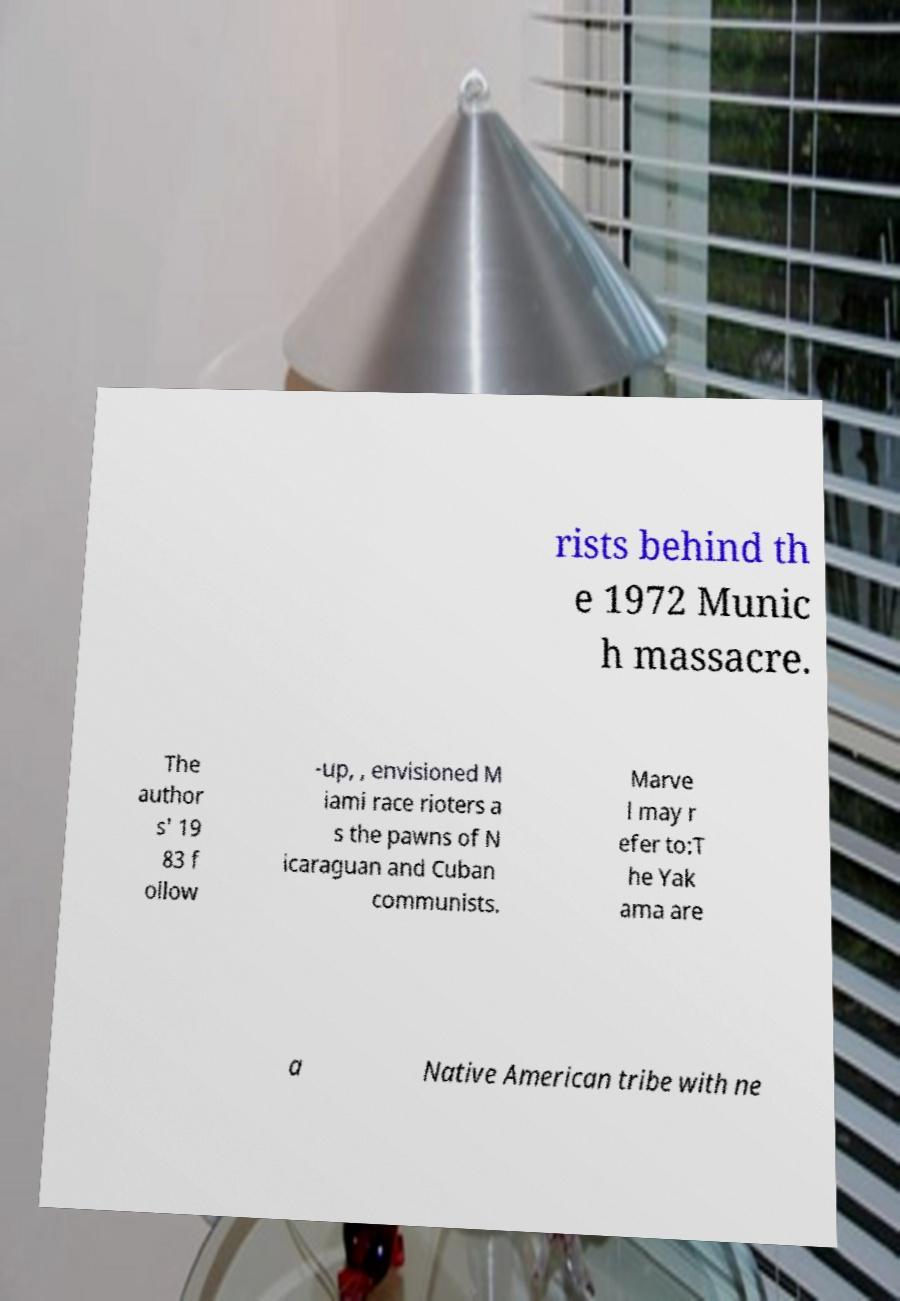Could you assist in decoding the text presented in this image and type it out clearly? rists behind th e 1972 Munic h massacre. The author s' 19 83 f ollow -up, , envisioned M iami race rioters a s the pawns of N icaraguan and Cuban communists. Marve l may r efer to:T he Yak ama are a Native American tribe with ne 